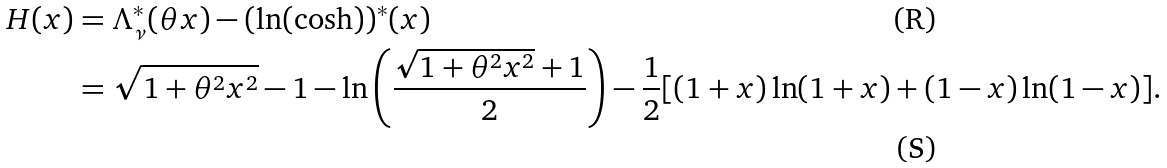<formula> <loc_0><loc_0><loc_500><loc_500>H ( x ) & = \Lambda _ { \nu } ^ { * } ( \theta x ) - ( \ln ( \cosh ) ) ^ { * } ( x ) \\ & = \sqrt { 1 + \theta ^ { 2 } x ^ { 2 } } - 1 - \ln \left ( \frac { \sqrt { 1 + \theta ^ { 2 } x ^ { 2 } } + 1 } { 2 } \right ) - \frac { 1 } { 2 } [ ( 1 + x ) \ln ( 1 + x ) + ( 1 - x ) \ln ( 1 - x ) ] .</formula> 